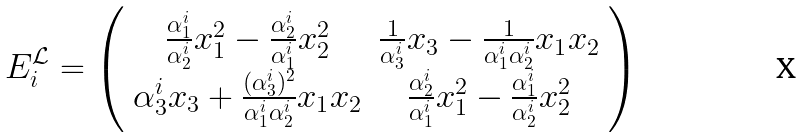<formula> <loc_0><loc_0><loc_500><loc_500>E _ { i } ^ { \mathcal { L } } = \left ( \begin{array} { c c } \frac { \alpha _ { 1 } ^ { i } } { \alpha _ { 2 } ^ { i } } x _ { 1 } ^ { 2 } - \frac { \alpha _ { 2 } ^ { i } } { \alpha _ { 1 } ^ { i } } x _ { 2 } ^ { 2 } & \frac { 1 } { \alpha _ { 3 } ^ { i } } x _ { 3 } - \frac { 1 } { \alpha _ { 1 } ^ { i } \alpha _ { 2 } ^ { i } } x _ { 1 } x _ { 2 } \\ \alpha _ { 3 } ^ { i } x _ { 3 } + \frac { ( \alpha _ { 3 } ^ { i } ) ^ { 2 } } { \alpha _ { 1 } ^ { i } \alpha _ { 2 } ^ { i } } x _ { 1 } x _ { 2 } & \frac { \alpha _ { 2 } ^ { i } } { \alpha _ { 1 } ^ { i } } x _ { 1 } ^ { 2 } - \frac { \alpha _ { 1 } ^ { i } } { \alpha _ { 2 } ^ { i } } x _ { 2 } ^ { 2 } \end{array} \right )</formula> 